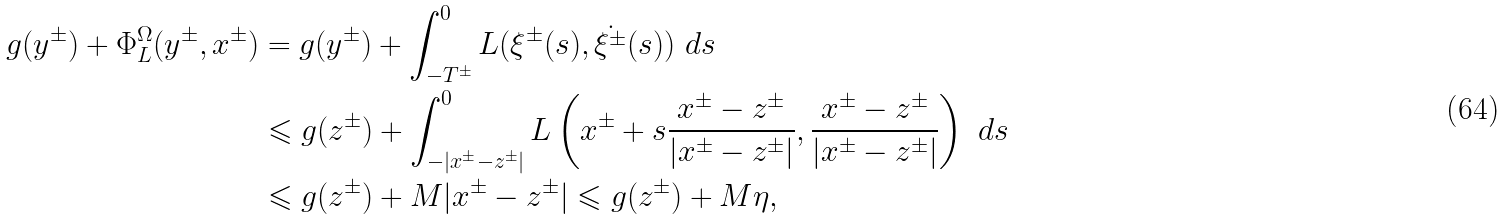Convert formula to latex. <formula><loc_0><loc_0><loc_500><loc_500>g ( y ^ { \pm } ) + \Phi _ { L } ^ { \Omega } ( y ^ { \pm } , x ^ { \pm } ) & = g ( y ^ { \pm } ) + \int ^ { 0 } _ { - T ^ { \pm } } L ( \xi ^ { \pm } ( s ) , \dot { \xi ^ { \pm } } ( s ) ) \ d s \\ & \leqslant g ( z ^ { \pm } ) + \int ^ { 0 } _ { - | x ^ { \pm } - z ^ { \pm } | } L \left ( x ^ { \pm } + s \frac { x ^ { \pm } - z ^ { \pm } } { | x ^ { \pm } - z ^ { \pm } | } , \frac { x ^ { \pm } - z ^ { \pm } } { | x ^ { \pm } - z ^ { \pm } | } \right ) \ d s \\ & \leqslant g ( z ^ { \pm } ) + M | x ^ { \pm } - z ^ { \pm } | \leqslant g ( z ^ { \pm } ) + M \eta ,</formula> 